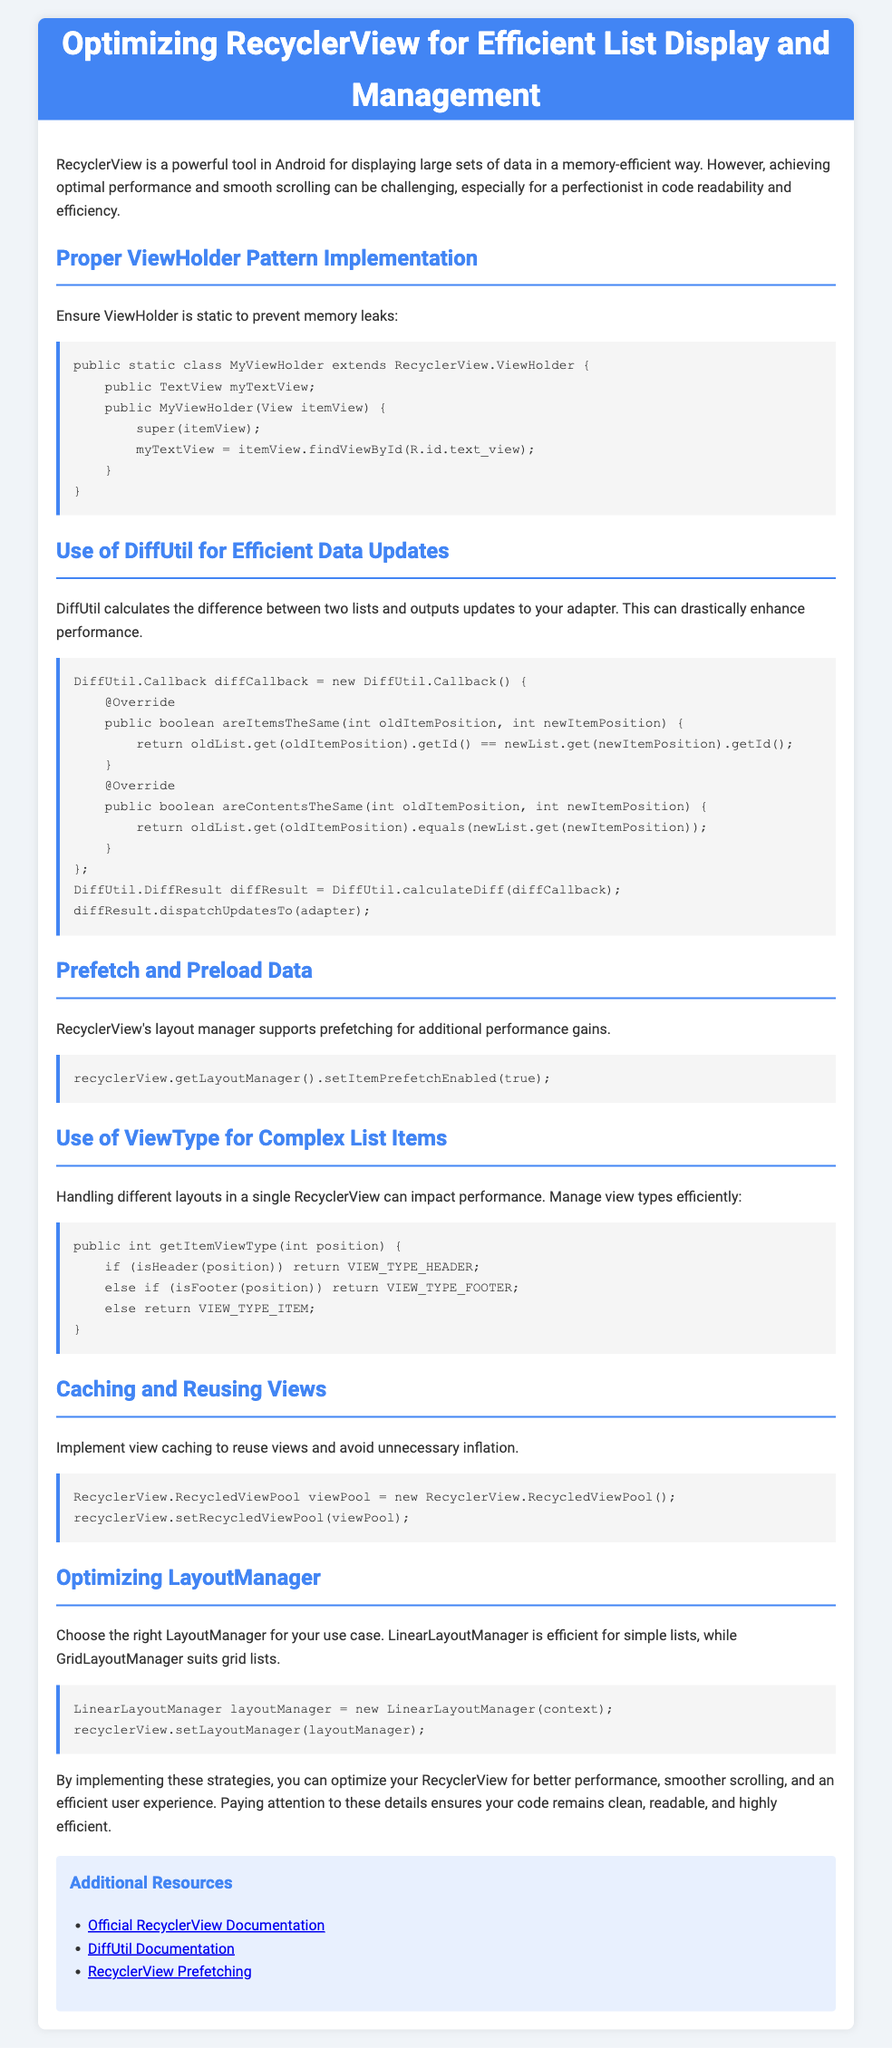What is the main title of the document? The main title of the document is found at the top of the page.
Answer: Optimizing RecyclerView for Efficient List Display and Management What is the purpose of DiffUtil? DiffUtil is mentioned as a tool to enhance performance by calculating differences between lists.
Answer: Efficient Data Updates What layout manager is recommended for simple lists? The document provides a specific recommendation for layout managers used in RecyclerView.
Answer: LinearLayoutManager What is one strategy mentioned for handling complex list items? The document discusses managing different layouts in a single RecyclerView through a specific method.
Answer: ViewType What does the document suggest for preventing memory leaks in ViewHolder? A specific implementation detail is mentioned to achieve this goal.
Answer: Static ViewHolder What coding technique is recommended for view recycling? The document advises implementing a specific coding practice to optimize view management.
Answer: View Caching How does prefetching improve performance in RecyclerView? Prefetching is mentioned as a way to achieve additional performance gains in RecyclerView.
Answer: Additional Performance Gains What is the first heading in the document? The first major section discusses an implementation detail crucial for RecyclerView.
Answer: Proper ViewHolder Pattern Implementation What type of document is this? The format and content indicate the document's focus on instructions for developers.
Answer: Assembly Instructions 